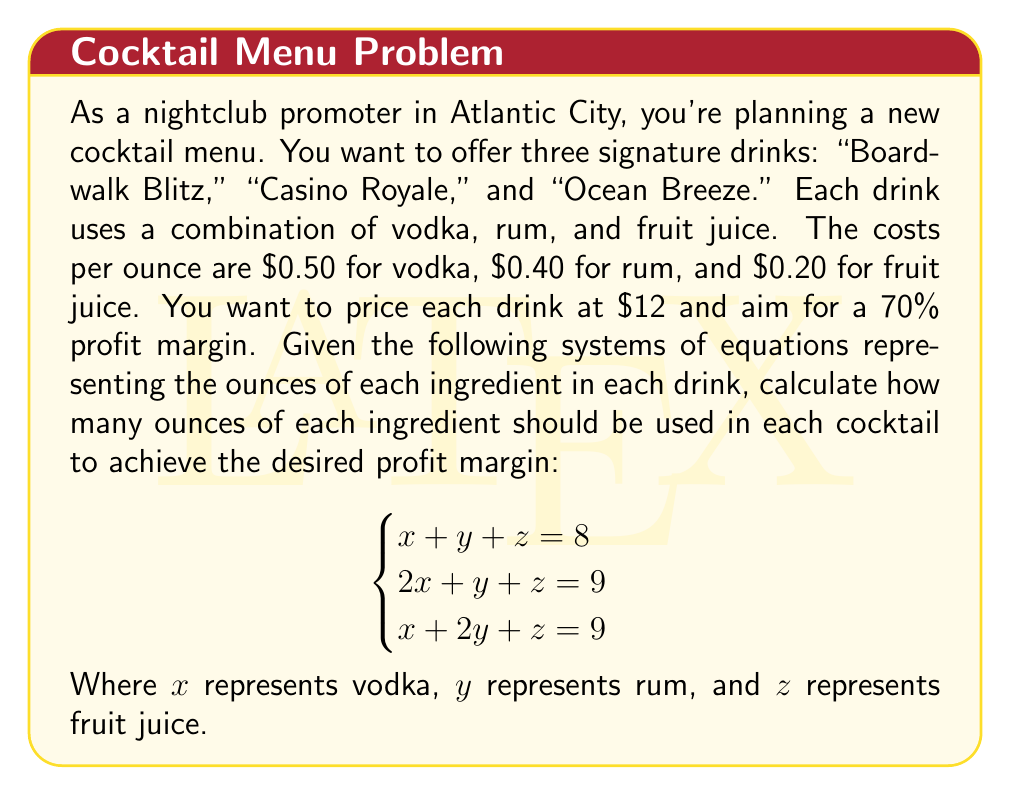Provide a solution to this math problem. Let's approach this step-by-step:

1) First, we need to solve the system of equations to find the amounts of each ingredient:

   $$\begin{cases}
   x + y + z = 8 \\
   2x + y + z = 9 \\
   x + 2y + z = 9
   \end{cases}$$

2) Subtracting the first equation from the second and third:

   $$\begin{cases}
   x = 1 \\
   y = 1
   \end{cases}$$

3) Substituting these values into the first equation:

   $$1 + 1 + z = 8$$
   $$z = 6$$

4) So, each drink contains 1 oz vodka, 1 oz rum, and 6 oz fruit juice.

5) Now, let's calculate the cost of each drink:

   $$(1 \times $0.50) + (1 \times $0.40) + (6 \times $0.20) = $0.50 + $0.40 + $1.20 = $2.10$$

6) The selling price is $12. To calculate the profit margin:

   $$\text{Profit Margin} = \frac{\text{Revenue} - \text{Cost}}{\text{Revenue}} \times 100\%$$

   $$= \frac{$12 - $2.10}{$12} \times 100\% = 82.5\%$$

7) This exceeds our target of 70% profit margin. To achieve exactly 70% profit margin:

   $$0.70 = \frac{$12 - \text{Cost}}{$12}$$
   $$\text{Cost} = $12 - (0.70 \times $12) = $3.60$$

8) To reach this cost while maintaining the same ratio of ingredients, we need to scale up our original recipe by a factor of:

   $$\frac{$3.60}{$2.10} = 1.714$$

9) Therefore, the final recipe for each drink should be:

   Vodka: $1 \times 1.714 = 1.714$ oz
   Rum: $1 \times 1.714 = 1.714$ oz
   Fruit Juice: $6 \times 1.714 = 10.284$ oz

   Total: 13.712 oz
Answer: 1.714 oz vodka, 1.714 oz rum, 10.284 oz fruit juice 